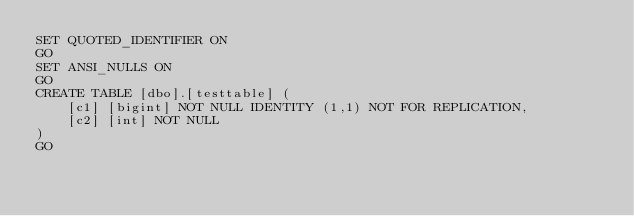Convert code to text. <code><loc_0><loc_0><loc_500><loc_500><_SQL_>SET QUOTED_IDENTIFIER ON
GO
SET ANSI_NULLS ON
GO
CREATE TABLE [dbo].[testtable] (
    [c1] [bigint] NOT NULL IDENTITY (1,1) NOT FOR REPLICATION,
    [c2] [int] NOT NULL
)
GO
</code> 